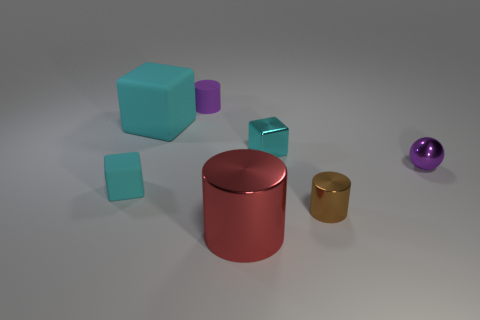Subtract all cyan cubes. How many were subtracted if there are1cyan cubes left? 2 Add 1 small gray rubber balls. How many objects exist? 8 Subtract all spheres. How many objects are left? 6 Subtract all metal cylinders. Subtract all large cyan rubber objects. How many objects are left? 4 Add 6 small cyan blocks. How many small cyan blocks are left? 8 Add 1 small cyan rubber things. How many small cyan rubber things exist? 2 Subtract 0 brown blocks. How many objects are left? 7 